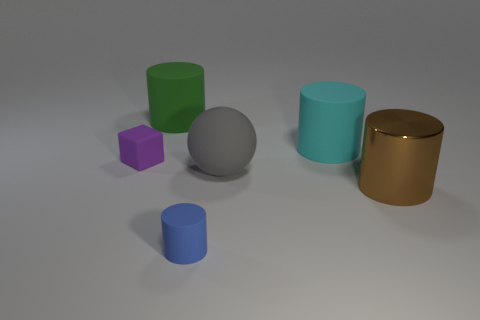Subtract all metal cylinders. How many cylinders are left? 3 Subtract all blue cylinders. How many cylinders are left? 3 Add 2 tiny cylinders. How many objects exist? 8 Subtract all red cylinders. Subtract all green blocks. How many cylinders are left? 4 Subtract all cylinders. How many objects are left? 2 Subtract 1 cyan cylinders. How many objects are left? 5 Subtract all small brown metal spheres. Subtract all large green cylinders. How many objects are left? 5 Add 6 tiny purple cubes. How many tiny purple cubes are left? 7 Add 1 rubber balls. How many rubber balls exist? 2 